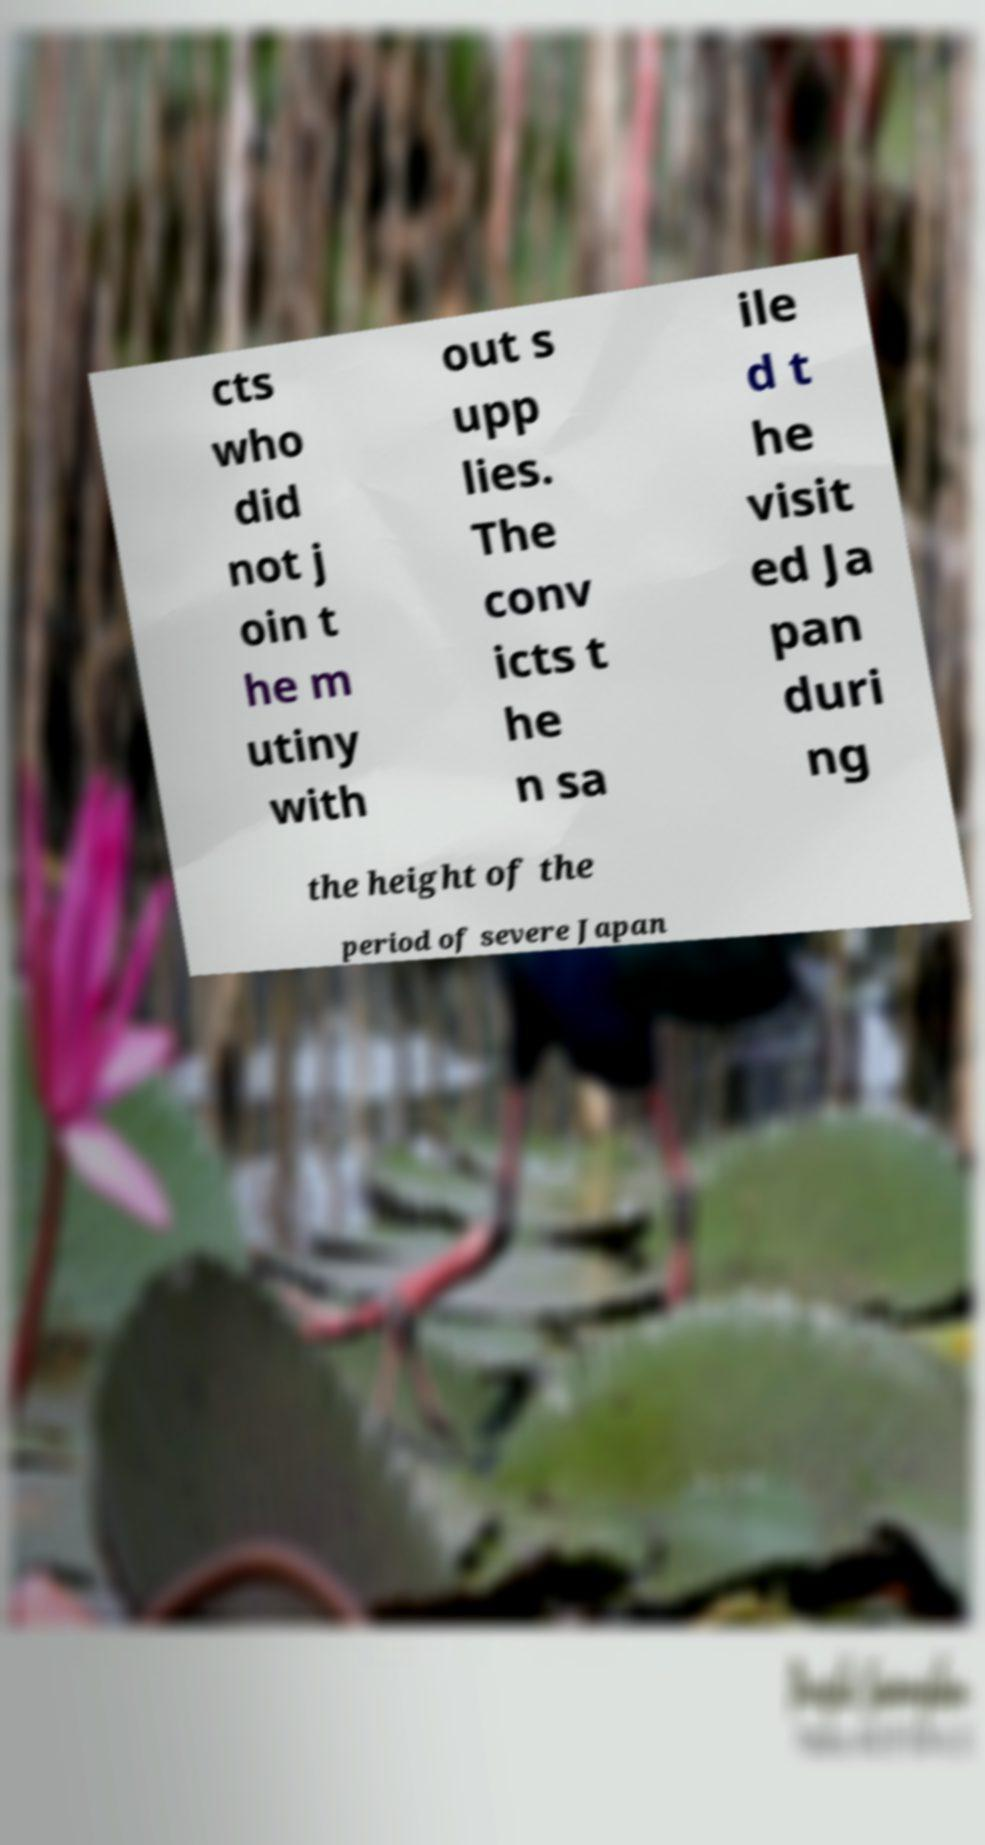Could you assist in decoding the text presented in this image and type it out clearly? cts who did not j oin t he m utiny with out s upp lies. The conv icts t he n sa ile d t he visit ed Ja pan duri ng the height of the period of severe Japan 